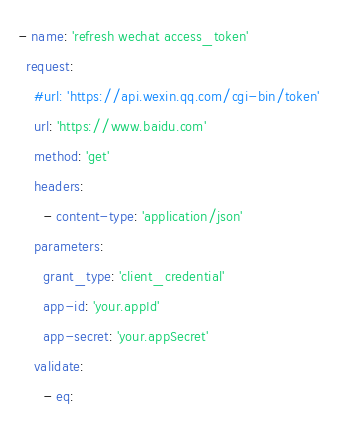Convert code to text. <code><loc_0><loc_0><loc_500><loc_500><_YAML_>- name: 'refresh wechat access_token'
  request:
    #url: 'https://api.wexin.qq.com/cgi-bin/token'
    url: 'https://www.baidu.com'
    method: 'get'
    headers:
      - content-type: 'application/json'
    parameters:
      grant_type: 'client_credential'
      app-id: 'your.appId'
      app-secret: 'your.appSecret'
    validate:
      - eq:</code> 